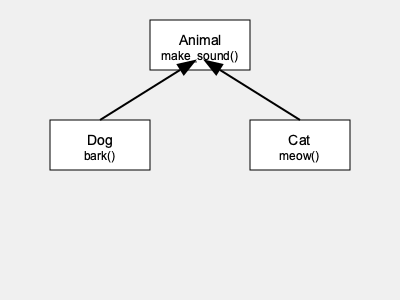Based on the class inheritance diagram, which method would be inherited by both the Dog and Cat classes from their parent class, and how would you call this method on an instance of the Dog class? To answer this question, let's break down the class inheritance diagram and understand its components:

1. We see three classes: Animal, Dog, and Cat.
2. The Animal class is at the top of the hierarchy, with an arrow pointing from both Dog and Cat to Animal. This indicates that Dog and Cat are subclasses of Animal (i.e., they inherit from Animal).
3. The Animal class has a method called make_sound().
4. The Dog class has a method called bark().
5. The Cat class has a method called meow().

Now, let's analyze the inheritance:

1. Since Dog and Cat inherit from Animal, they will inherit all the methods defined in the Animal class.
2. The only method defined in the Animal class is make_sound().
3. Therefore, both Dog and Cat will inherit the make_sound() method.

To call the inherited make_sound() method on an instance of the Dog class:

1. First, you would create an instance of the Dog class, e.g., my_dog = Dog()
2. Then, you would call the make_sound() method on this instance: my_dog.make_sound()

It's important to note that while Dog and Cat inherit make_sound(), they may override this method in their own implementations to provide specific behavior (e.g., Dog might implement make_sound() to call bark()).
Answer: make_sound(); my_dog.make_sound() 